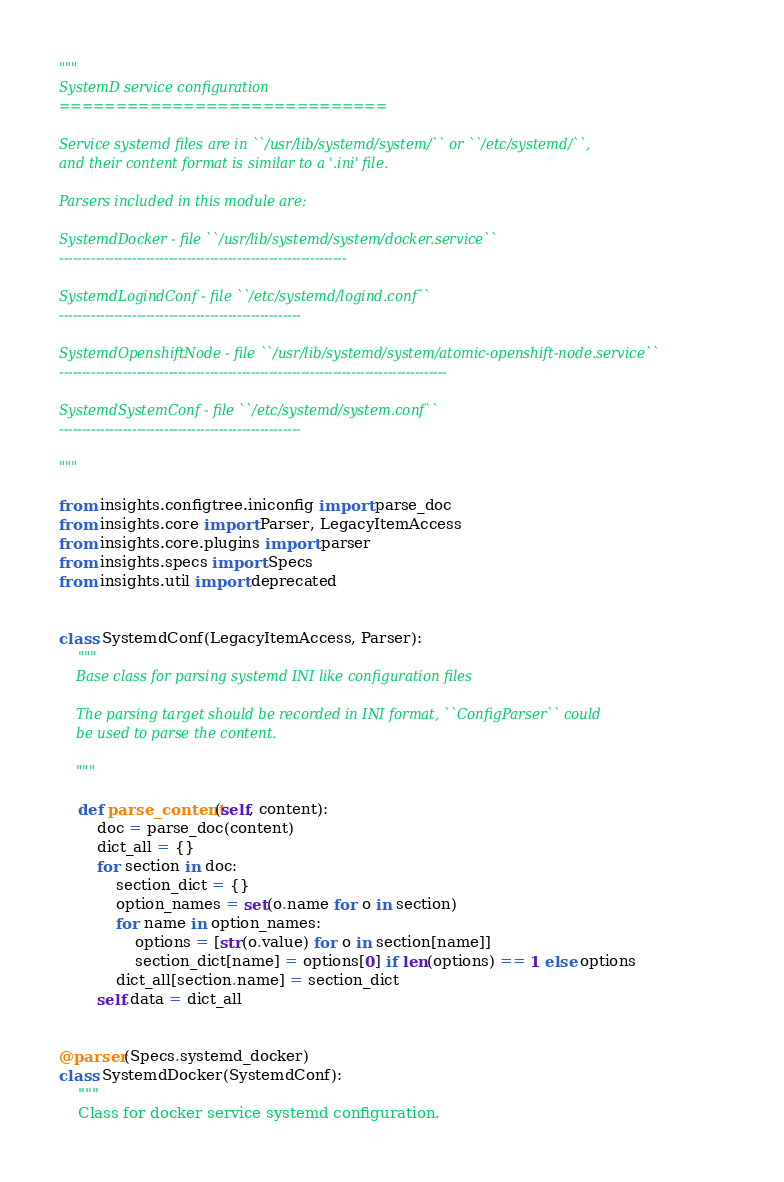Convert code to text. <code><loc_0><loc_0><loc_500><loc_500><_Python_>"""
SystemD service configuration
=============================

Service systemd files are in ``/usr/lib/systemd/system/`` or ``/etc/systemd/``,
and their content format is similar to a '.ini' file.

Parsers included in this module are:

SystemdDocker - file ``/usr/lib/systemd/system/docker.service``
---------------------------------------------------------------

SystemdLogindConf - file ``/etc/systemd/logind.conf``
-----------------------------------------------------

SystemdOpenshiftNode - file ``/usr/lib/systemd/system/atomic-openshift-node.service``
-------------------------------------------------------------------------------------

SystemdSystemConf - file ``/etc/systemd/system.conf``
-----------------------------------------------------

"""

from insights.configtree.iniconfig import parse_doc
from insights.core import Parser, LegacyItemAccess
from insights.core.plugins import parser
from insights.specs import Specs
from insights.util import deprecated


class SystemdConf(LegacyItemAccess, Parser):
    """
    Base class for parsing systemd INI like configuration files

    The parsing target should be recorded in INI format, ``ConfigParser`` could
    be used to parse the content.

    """

    def parse_content(self, content):
        doc = parse_doc(content)
        dict_all = {}
        for section in doc:
            section_dict = {}
            option_names = set(o.name for o in section)
            for name in option_names:
                options = [str(o.value) for o in section[name]]
                section_dict[name] = options[0] if len(options) == 1 else options
            dict_all[section.name] = section_dict
        self.data = dict_all


@parser(Specs.systemd_docker)
class SystemdDocker(SystemdConf):
    """
    Class for docker service systemd configuration.
</code> 